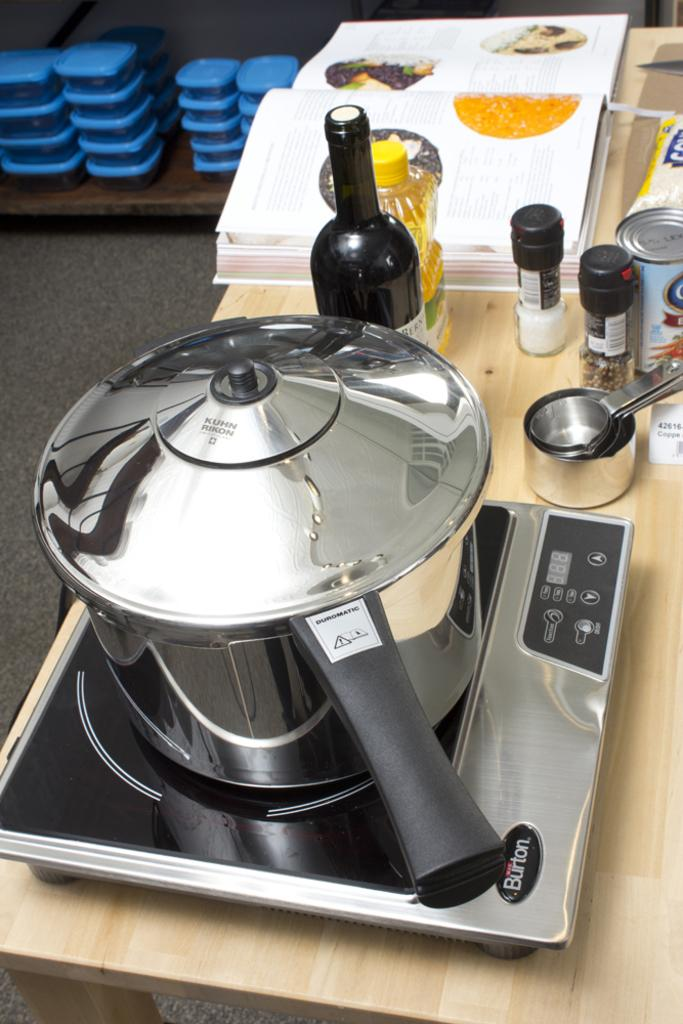<image>
Create a compact narrative representing the image presented. a pot with a lid above a burner that says 'burton' on it 